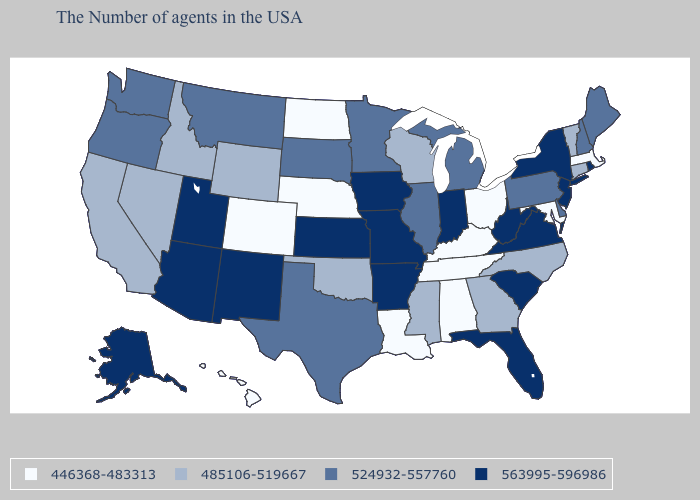What is the value of Louisiana?
Give a very brief answer. 446368-483313. Among the states that border Montana , does North Dakota have the lowest value?
Quick response, please. Yes. What is the value of Maryland?
Quick response, please. 446368-483313. Does Texas have the lowest value in the USA?
Write a very short answer. No. Which states hav the highest value in the West?
Keep it brief. New Mexico, Utah, Arizona, Alaska. Does Wisconsin have a lower value than Wyoming?
Quick response, please. No. Name the states that have a value in the range 524932-557760?
Be succinct. Maine, New Hampshire, Delaware, Pennsylvania, Michigan, Illinois, Minnesota, Texas, South Dakota, Montana, Washington, Oregon. Among the states that border New Hampshire , does Vermont have the highest value?
Short answer required. No. Among the states that border North Carolina , which have the lowest value?
Be succinct. Tennessee. Does Illinois have the lowest value in the USA?
Give a very brief answer. No. Name the states that have a value in the range 485106-519667?
Keep it brief. Vermont, Connecticut, North Carolina, Georgia, Wisconsin, Mississippi, Oklahoma, Wyoming, Idaho, Nevada, California. What is the value of Alabama?
Keep it brief. 446368-483313. What is the lowest value in states that border Delaware?
Give a very brief answer. 446368-483313. Name the states that have a value in the range 446368-483313?
Short answer required. Massachusetts, Maryland, Ohio, Kentucky, Alabama, Tennessee, Louisiana, Nebraska, North Dakota, Colorado, Hawaii. Which states have the highest value in the USA?
Give a very brief answer. Rhode Island, New York, New Jersey, Virginia, South Carolina, West Virginia, Florida, Indiana, Missouri, Arkansas, Iowa, Kansas, New Mexico, Utah, Arizona, Alaska. 